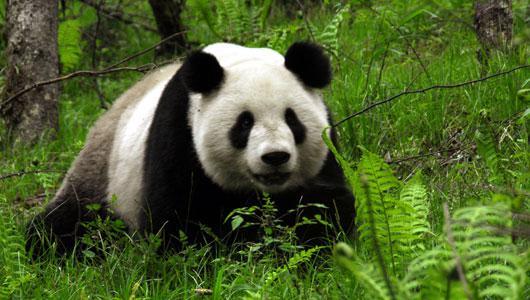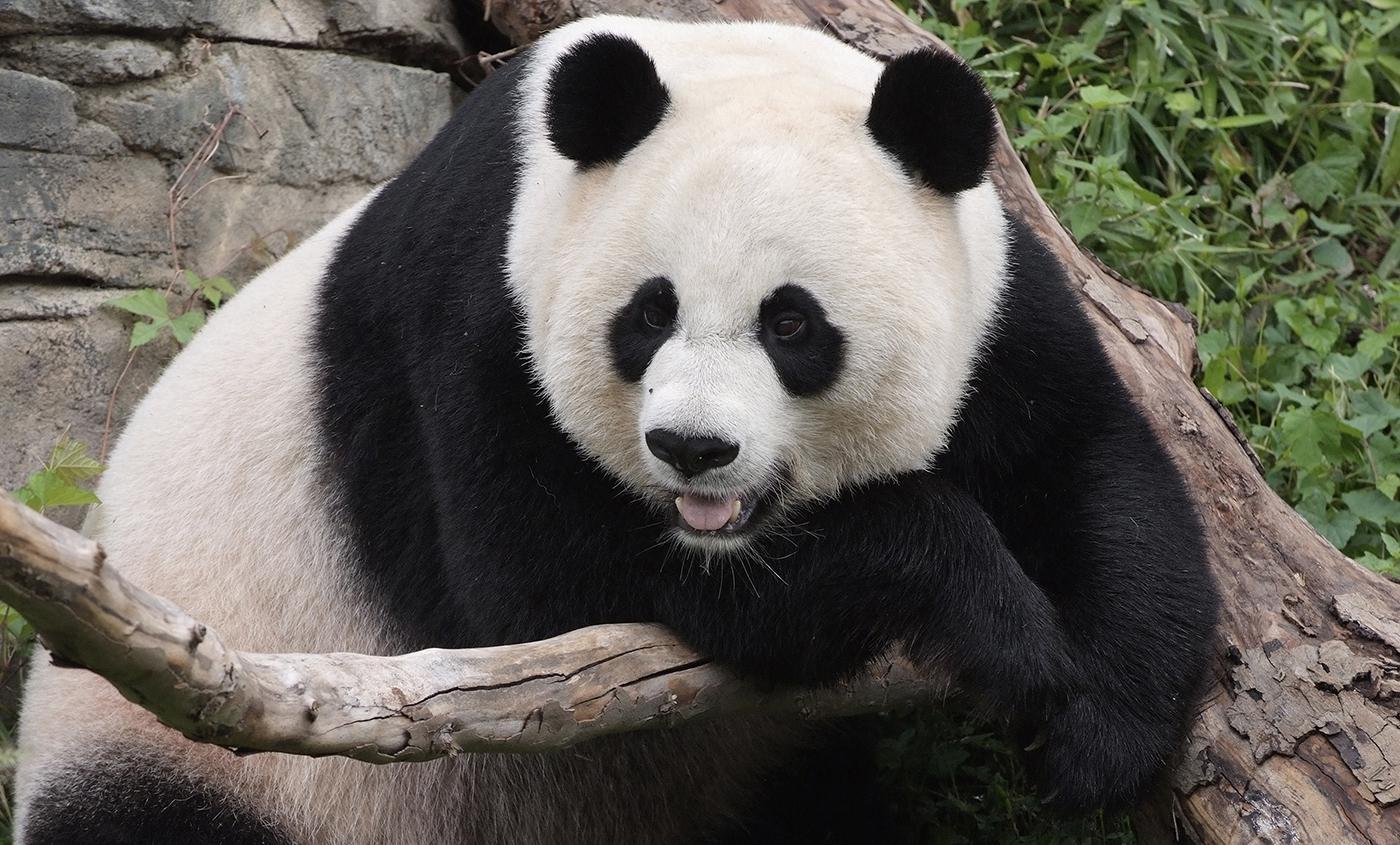The first image is the image on the left, the second image is the image on the right. Assess this claim about the two images: "The panda in the right image has paws on a branch.". Correct or not? Answer yes or no. Yes. The first image is the image on the left, the second image is the image on the right. For the images shown, is this caption "There is exactly one panda with all feet on the ground in one of the images" true? Answer yes or no. Yes. 